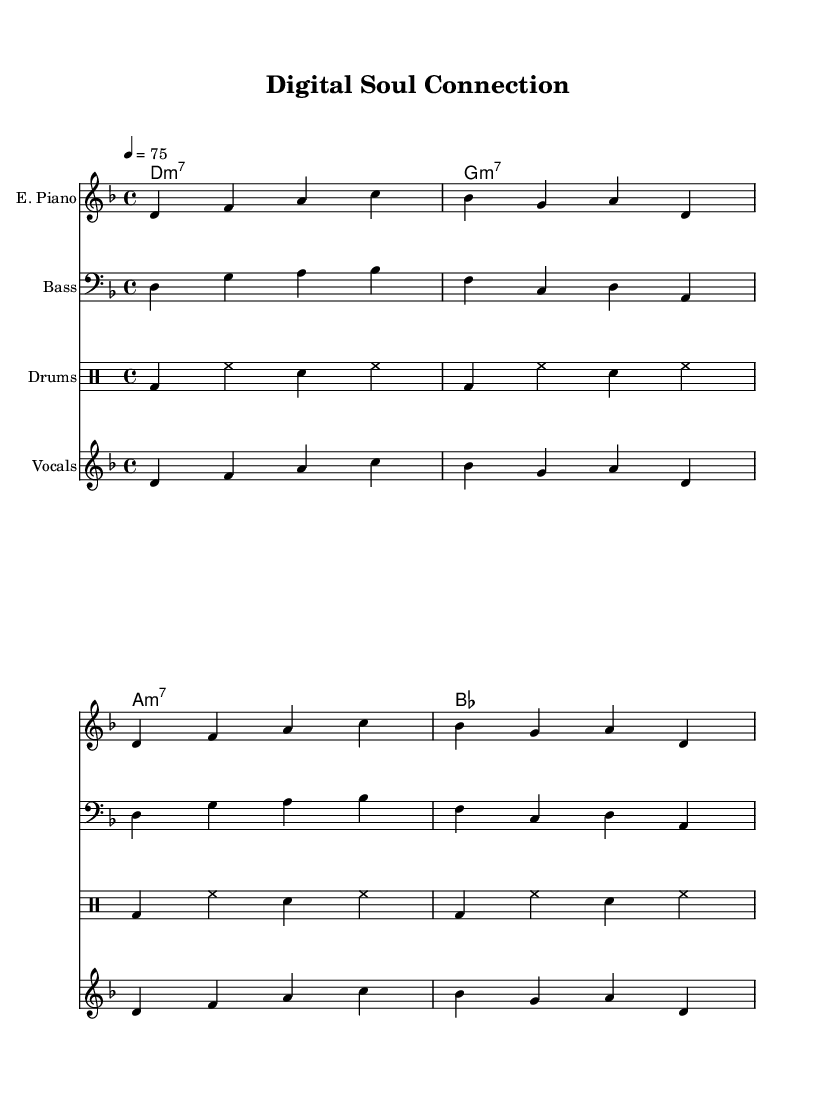What is the key signature of this music? The key signature is D minor, indicated by the presence of one flat (B♭) at the beginning of the staff lines.
Answer: D minor What is the time signature of this music? The time signature is 4/4, shown at the beginning of the sheet music as a fraction indicating four beats per measure.
Answer: 4/4 What is the tempo marking of this piece? The tempo marking indicates a speed of 75 beats per minute, specified with the notation "4 = 75" at the beginning of the score.
Answer: 75 How many measures are in the electric piano part? The electric piano part contains four measures, visually counted by the number of bar lines present before repeating sections.
Answer: Four What chords are used in the synth pad section? The chords in the synth pad section are D minor 7, G minor 7, A minor 7, and B♭, as indicated by the chord symbols above the staff.
Answer: D minor 7, G minor 7, A minor 7, B♭ Which instrument plays the melody in this song? The vocals part plays the melody, indicated by the specific staff labeled "Vocals," presenting both the melody notes and the corresponding lyrics.
Answer: Vocals What style of music does this piece represent? This piece represents the style of funk, characterized by its rhythmic groove and soulful ballad essence, evident in the instrumentation and lyrical themes.
Answer: Funk 